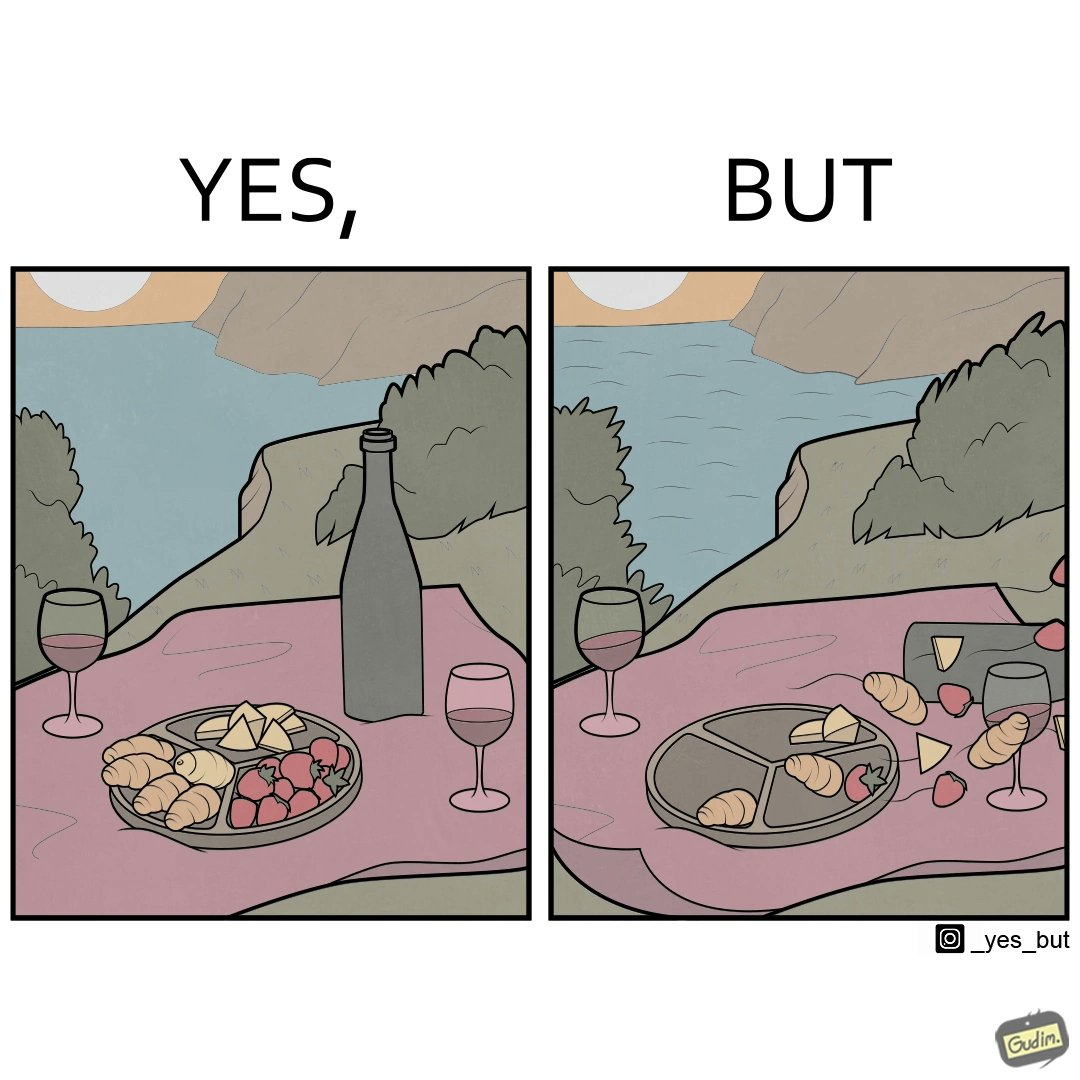Provide a description of this image. The environment is feeling very relaxing in the right image but the consequence is that the food is flying die to powerful wind. So the person is not able to eat it properly. 